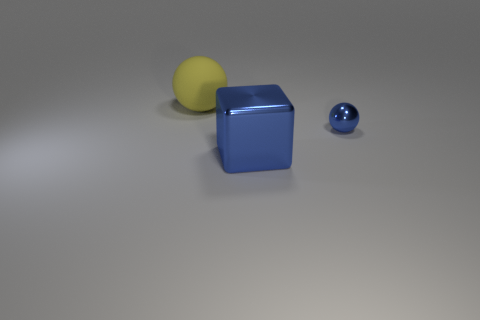Do the rubber sphere and the object in front of the tiny shiny thing have the same color?
Your answer should be very brief. No. How many tiny metallic objects are the same color as the tiny ball?
Your answer should be very brief. 0. How big is the ball on the right side of the thing that is on the left side of the blue metallic block?
Give a very brief answer. Small. What number of things are blue objects in front of the small ball or blue balls?
Your answer should be compact. 2. Are there any green rubber blocks that have the same size as the yellow sphere?
Ensure brevity in your answer.  No. There is a metal object in front of the blue ball; is there a metallic thing right of it?
Offer a very short reply. Yes. What number of spheres are either tiny blue metal objects or matte objects?
Your answer should be compact. 2. Are there any green objects that have the same shape as the small blue object?
Provide a succinct answer. No. The large blue object is what shape?
Make the answer very short. Cube. How many objects are either green cubes or big metal things?
Keep it short and to the point. 1. 